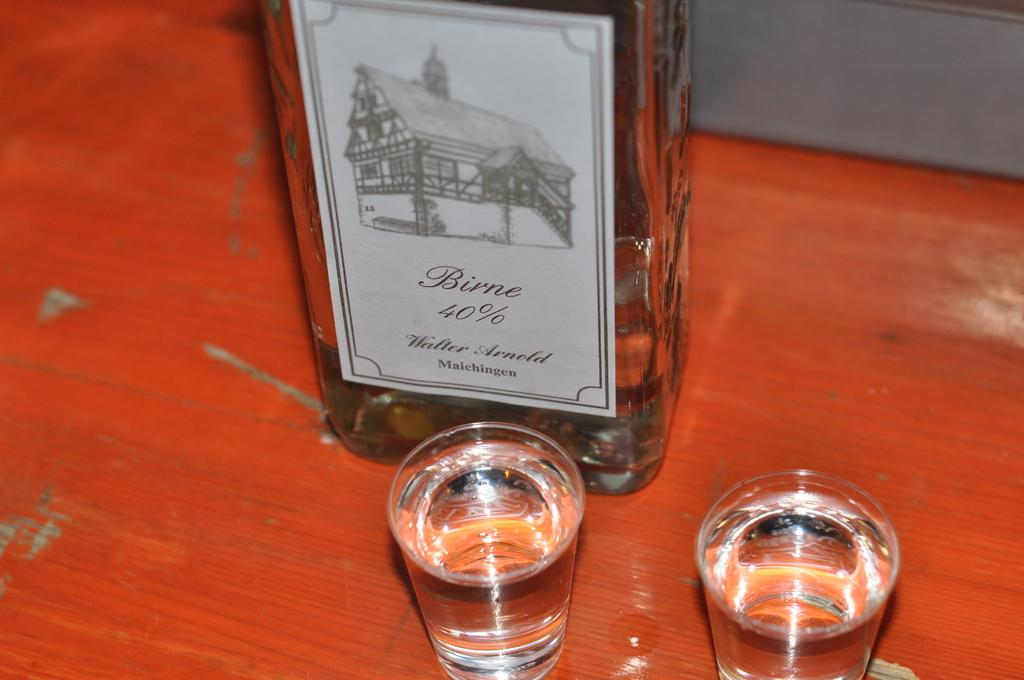Provide a one-sentence caption for the provided image. Two shot glasses full of liqour called Birne. 